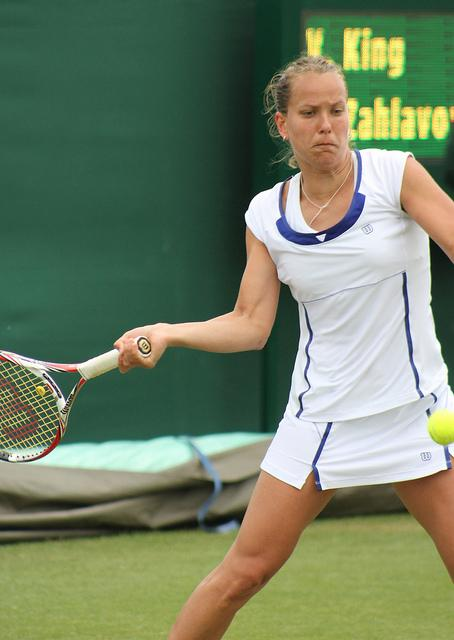What shot is this player making?

Choices:
A) serve
B) backhand
C) lob
D) forehand forehand 